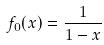Convert formula to latex. <formula><loc_0><loc_0><loc_500><loc_500>f _ { 0 } ( x ) = \frac { 1 } { 1 - x }</formula> 